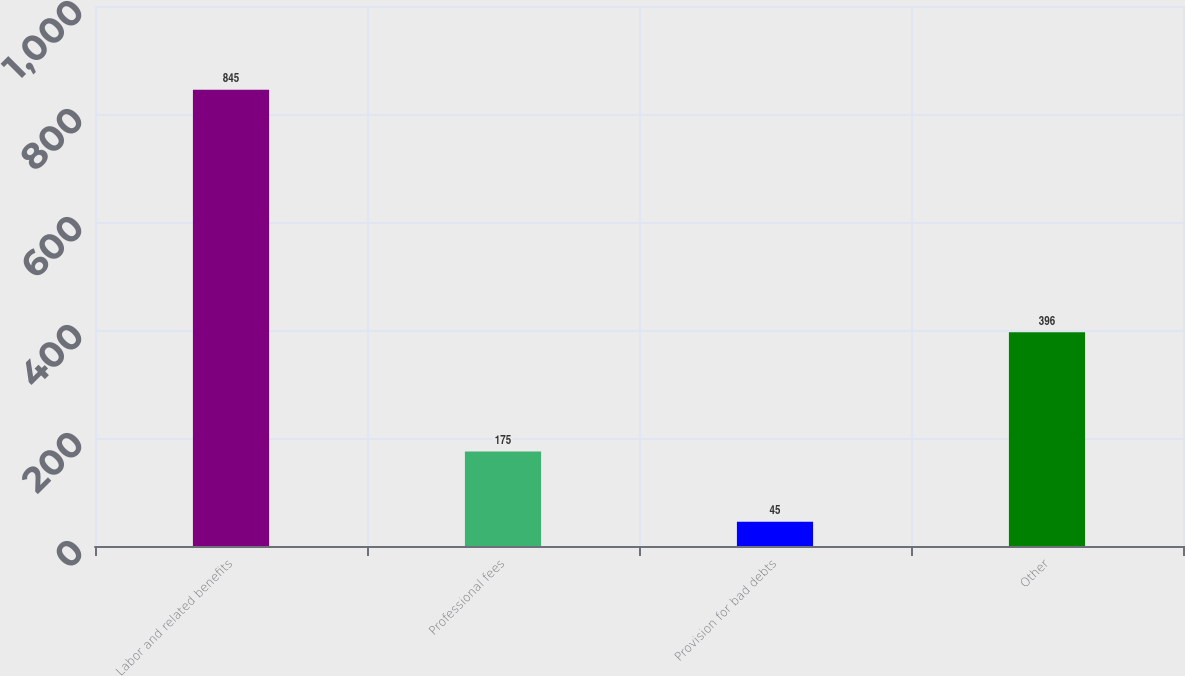Convert chart to OTSL. <chart><loc_0><loc_0><loc_500><loc_500><bar_chart><fcel>Labor and related benefits<fcel>Professional fees<fcel>Provision for bad debts<fcel>Other<nl><fcel>845<fcel>175<fcel>45<fcel>396<nl></chart> 